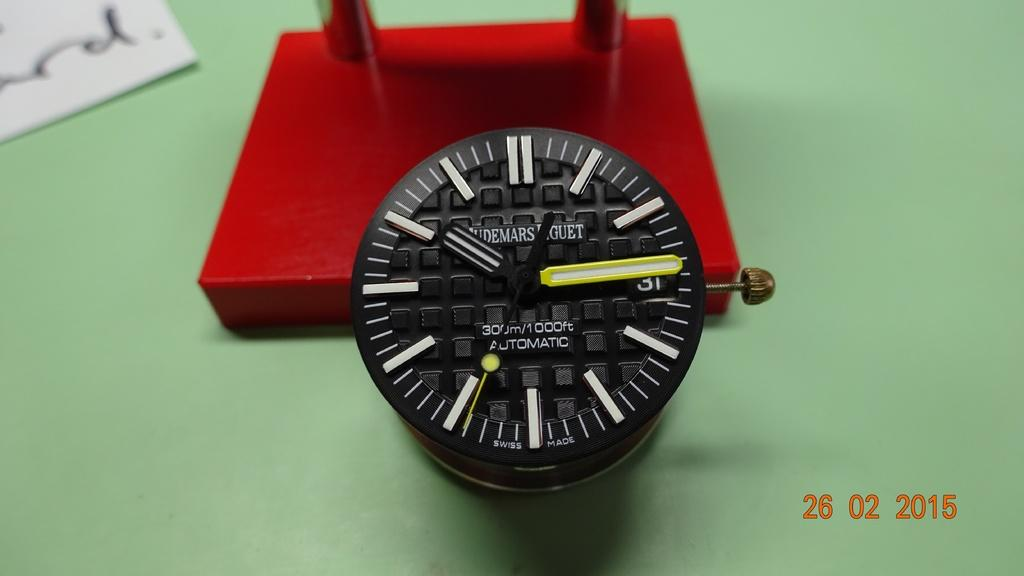<image>
Present a compact description of the photo's key features. A black watch on a red box and the watch has the word automatic on it. 